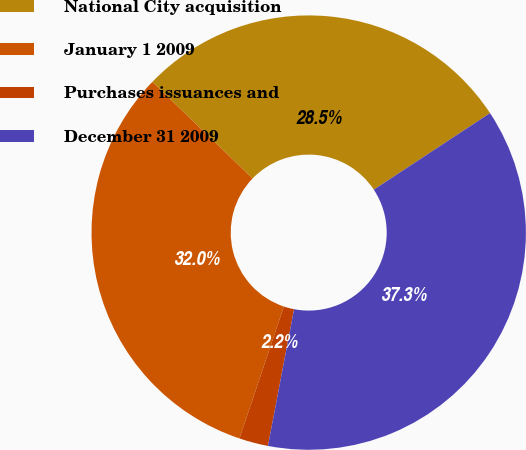Convert chart. <chart><loc_0><loc_0><loc_500><loc_500><pie_chart><fcel>National City acquisition<fcel>January 1 2009<fcel>Purchases issuances and<fcel>December 31 2009<nl><fcel>28.52%<fcel>32.04%<fcel>2.16%<fcel>37.28%<nl></chart> 